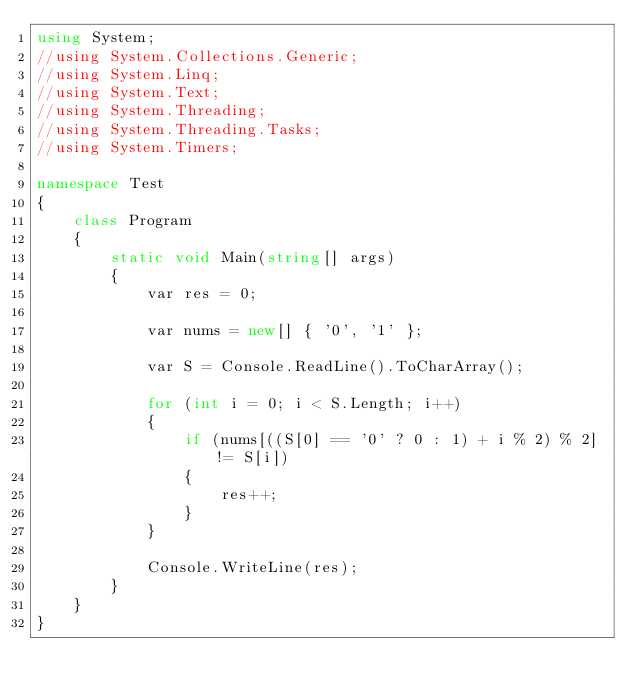<code> <loc_0><loc_0><loc_500><loc_500><_C#_>using System;
//using System.Collections.Generic;
//using System.Linq;
//using System.Text;
//using System.Threading;
//using System.Threading.Tasks;
//using System.Timers;

namespace Test
{
    class Program
    {
        static void Main(string[] args)
        {
            var res = 0;

            var nums = new[] { '0', '1' };

            var S = Console.ReadLine().ToCharArray();

            for (int i = 0; i < S.Length; i++)
            {
                if (nums[((S[0] == '0' ? 0 : 1) + i % 2) % 2] != S[i])
                {
                    res++;
                }
            }

            Console.WriteLine(res);
        }
    }
}
</code> 